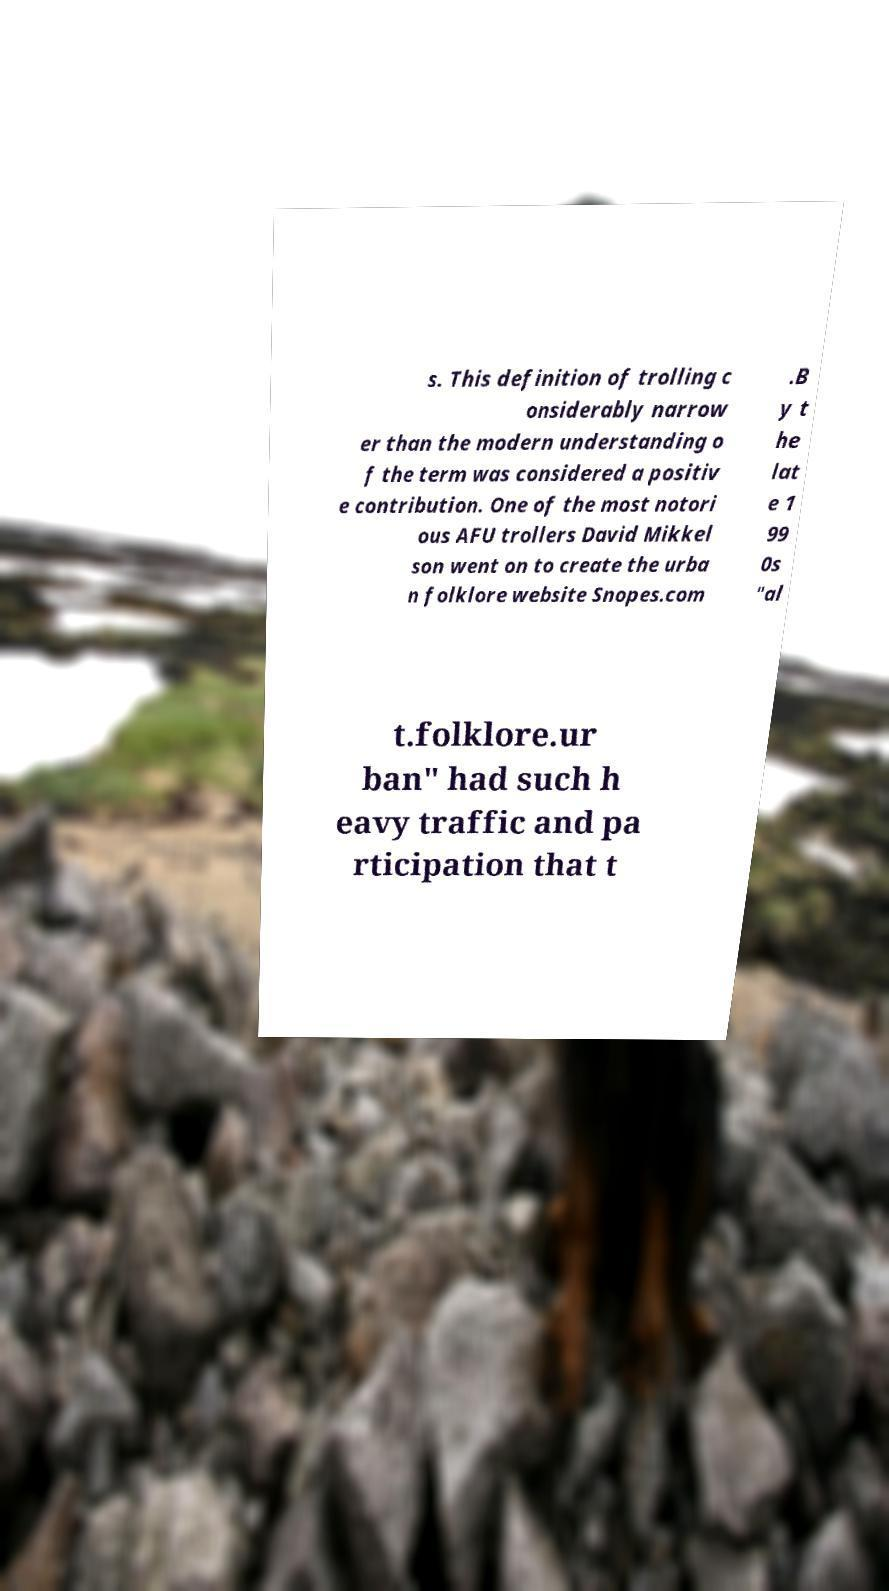Can you accurately transcribe the text from the provided image for me? s. This definition of trolling c onsiderably narrow er than the modern understanding o f the term was considered a positiv e contribution. One of the most notori ous AFU trollers David Mikkel son went on to create the urba n folklore website Snopes.com .B y t he lat e 1 99 0s "al t.folklore.ur ban" had such h eavy traffic and pa rticipation that t 